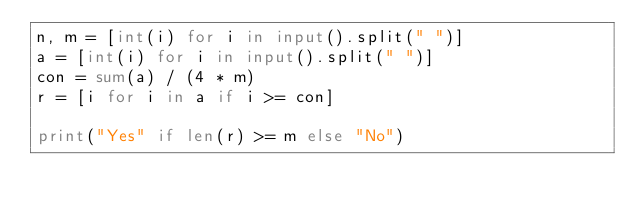Convert code to text. <code><loc_0><loc_0><loc_500><loc_500><_Python_>n, m = [int(i) for i in input().split(" ")]
a = [int(i) for i in input().split(" ")]
con = sum(a) / (4 * m)
r = [i for i in a if i >= con]

print("Yes" if len(r) >= m else "No")</code> 